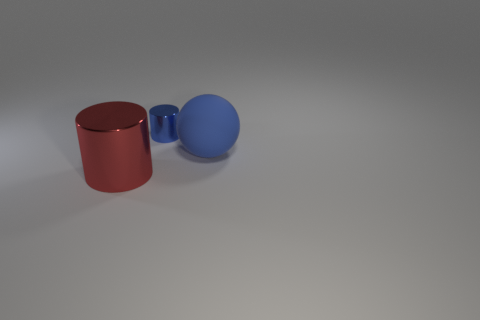Subtract 1 spheres. How many spheres are left? 0 Subtract all gray balls. Subtract all purple cylinders. How many balls are left? 1 Subtract all brown balls. How many red cylinders are left? 1 Subtract all big red cylinders. Subtract all large red things. How many objects are left? 1 Add 3 big blue balls. How many big blue balls are left? 4 Add 3 yellow shiny cylinders. How many yellow shiny cylinders exist? 3 Add 2 red things. How many objects exist? 5 Subtract 0 brown spheres. How many objects are left? 3 Subtract all balls. How many objects are left? 2 